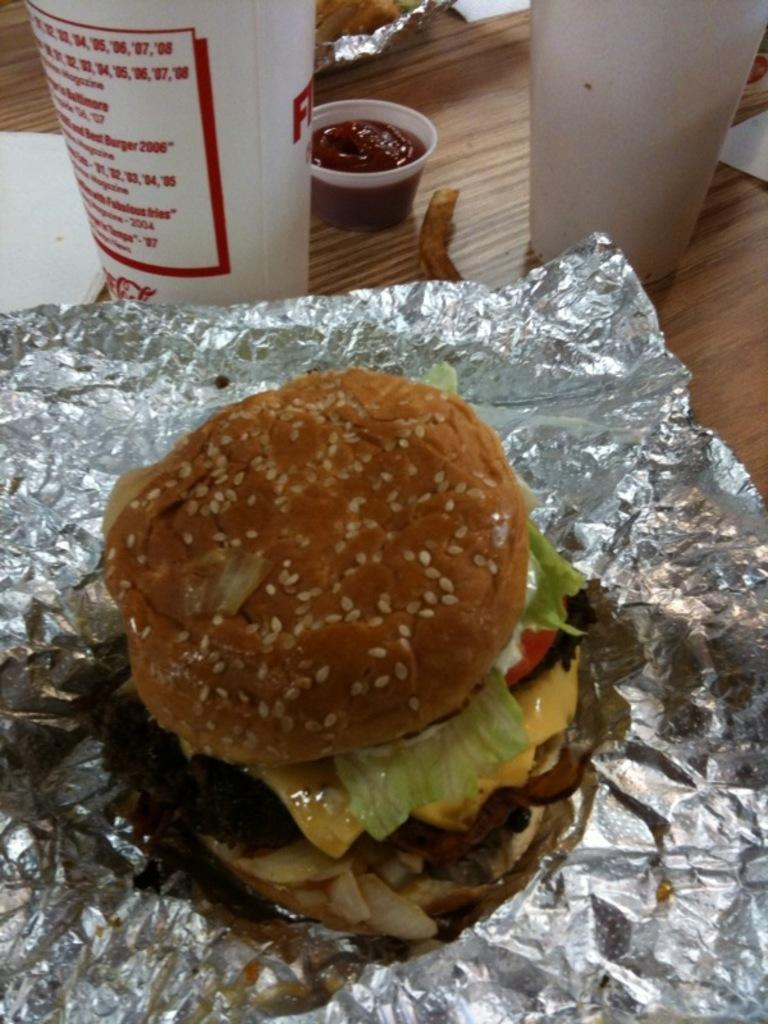What is the material used to wrap the food items in the image? The food items are wrapped in aluminium foils in the image. What type of containers are present for holding liquids? There are glasses in the image for holding liquids. What can be used for wiping or blowing one's nose in the image? Tissues are present in the image for wiping or blowing one's nose. What type of sauce is in the cup in the image? The cup in the image contains sauce. Where are all the items located in the image? All the items are on a table in the image. What type of watch is visible on the table in the image? There is no watch present in the image; it only features food items, glasses, tissues, and a cup with sauce on a table. What kind of art can be seen hanging on the wall in the image? There is no art or wall visible in the image; it only shows items on a table. 